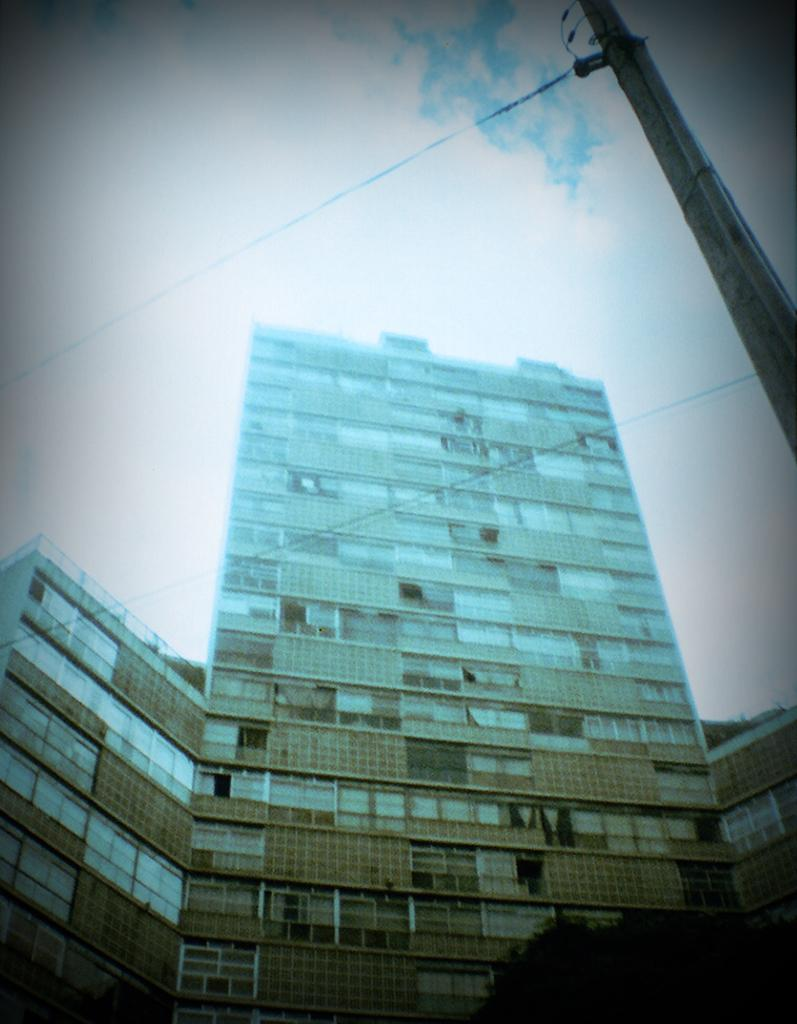What type of structures can be seen in the image? There are buildings in the image. What other natural elements are present in the image? There are trees in the image. What man-made object can be seen in the image? There is an electric pole in the image. What is connected to the electric pole? There are electric cables in the image. What can be seen in the background of the image? The sky is visible in the background of the image, and there are clouds in the sky. What type of string is being used for the discussion in the image? There is no discussion or string present in the image. How does the push affect the buildings in the image? There is no push or any indication of movement in the image; the buildings are stationary. 